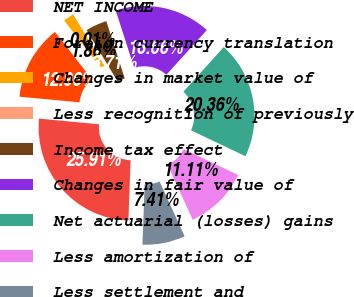<chart> <loc_0><loc_0><loc_500><loc_500><pie_chart><fcel>NET INCOME<fcel>Foreign currency translation<fcel>Changes in market value of<fcel>Less recognition of previously<fcel>Income tax effect<fcel>Changes in fair value of<fcel>Net actuarial (losses) gains<fcel>Less amortization of<fcel>Less settlement and<nl><fcel>25.91%<fcel>12.96%<fcel>1.86%<fcel>0.01%<fcel>3.71%<fcel>16.66%<fcel>20.36%<fcel>11.11%<fcel>7.41%<nl></chart> 